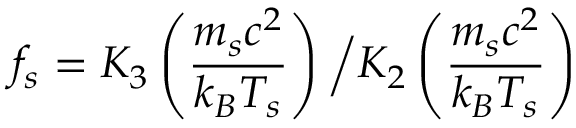<formula> <loc_0><loc_0><loc_500><loc_500>f _ { s } = K _ { 3 } \left ( \frac { m _ { s } c ^ { 2 } } { k _ { B } T _ { s } } \right ) \Big / K _ { 2 } \left ( \frac { m _ { s } c ^ { 2 } } { k _ { B } T _ { s } } \right )</formula> 